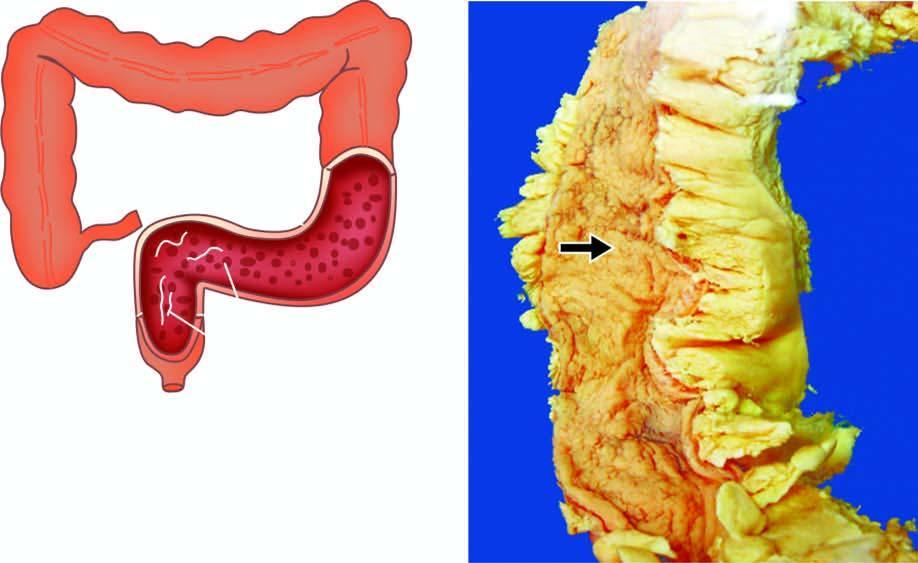re the haustral folds lost giving 'garden-hose appearance '?
Answer the question using a single word or phrase. Yes 